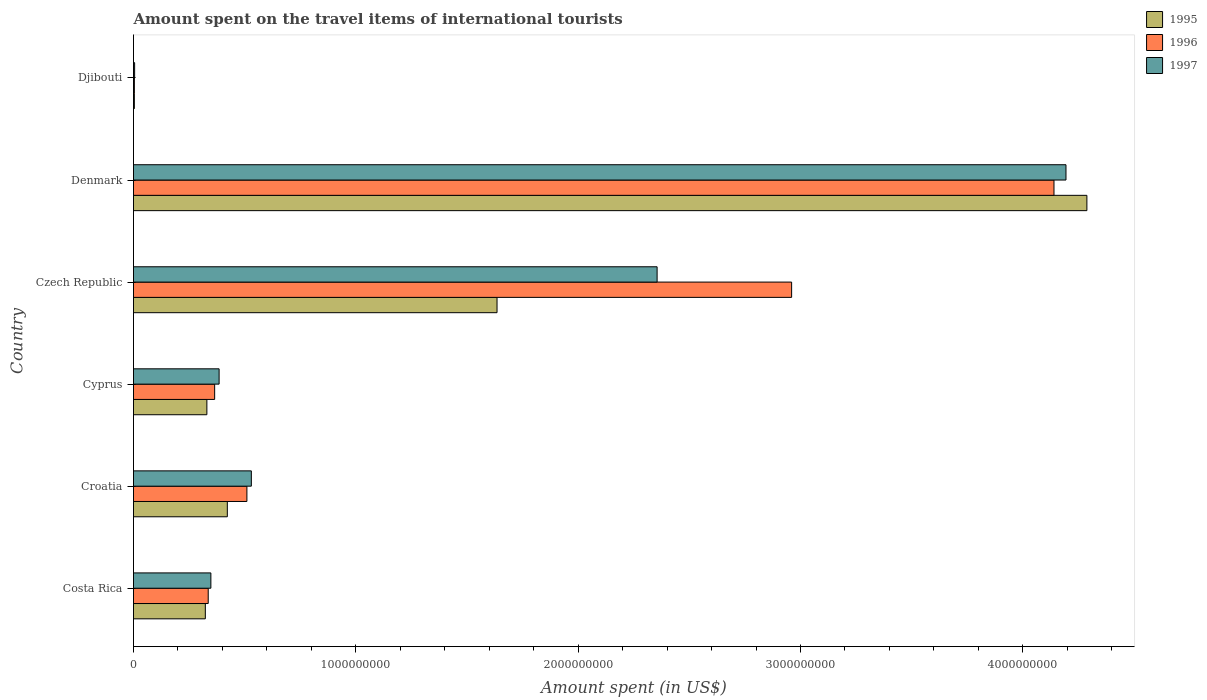How many groups of bars are there?
Your answer should be very brief. 6. How many bars are there on the 5th tick from the top?
Your answer should be very brief. 3. What is the label of the 4th group of bars from the top?
Your response must be concise. Cyprus. In how many cases, is the number of bars for a given country not equal to the number of legend labels?
Give a very brief answer. 0. What is the amount spent on the travel items of international tourists in 1995 in Djibouti?
Offer a terse response. 3.80e+06. Across all countries, what is the maximum amount spent on the travel items of international tourists in 1995?
Offer a terse response. 4.29e+09. Across all countries, what is the minimum amount spent on the travel items of international tourists in 1995?
Offer a terse response. 3.80e+06. In which country was the amount spent on the travel items of international tourists in 1995 maximum?
Provide a short and direct response. Denmark. In which country was the amount spent on the travel items of international tourists in 1996 minimum?
Ensure brevity in your answer.  Djibouti. What is the total amount spent on the travel items of international tourists in 1996 in the graph?
Provide a succinct answer. 8.31e+09. What is the difference between the amount spent on the travel items of international tourists in 1996 in Costa Rica and that in Cyprus?
Ensure brevity in your answer.  -2.90e+07. What is the difference between the amount spent on the travel items of international tourists in 1995 in Croatia and the amount spent on the travel items of international tourists in 1996 in Czech Republic?
Give a very brief answer. -2.54e+09. What is the average amount spent on the travel items of international tourists in 1997 per country?
Ensure brevity in your answer.  1.30e+09. What is the difference between the amount spent on the travel items of international tourists in 1995 and amount spent on the travel items of international tourists in 1997 in Cyprus?
Give a very brief answer. -5.50e+07. In how many countries, is the amount spent on the travel items of international tourists in 1995 greater than 3400000000 US$?
Provide a short and direct response. 1. What is the ratio of the amount spent on the travel items of international tourists in 1997 in Croatia to that in Czech Republic?
Provide a succinct answer. 0.23. What is the difference between the highest and the second highest amount spent on the travel items of international tourists in 1996?
Your response must be concise. 1.18e+09. What is the difference between the highest and the lowest amount spent on the travel items of international tourists in 1996?
Give a very brief answer. 4.14e+09. In how many countries, is the amount spent on the travel items of international tourists in 1996 greater than the average amount spent on the travel items of international tourists in 1996 taken over all countries?
Provide a short and direct response. 2. Is the sum of the amount spent on the travel items of international tourists in 1997 in Croatia and Cyprus greater than the maximum amount spent on the travel items of international tourists in 1996 across all countries?
Your response must be concise. No. What does the 1st bar from the top in Djibouti represents?
Keep it short and to the point. 1997. What does the 2nd bar from the bottom in Denmark represents?
Ensure brevity in your answer.  1996. Is it the case that in every country, the sum of the amount spent on the travel items of international tourists in 1996 and amount spent on the travel items of international tourists in 1997 is greater than the amount spent on the travel items of international tourists in 1995?
Your answer should be very brief. Yes. What is the difference between two consecutive major ticks on the X-axis?
Ensure brevity in your answer.  1.00e+09. Does the graph contain any zero values?
Offer a terse response. No. Does the graph contain grids?
Offer a terse response. No. Where does the legend appear in the graph?
Your answer should be compact. Top right. How many legend labels are there?
Provide a short and direct response. 3. How are the legend labels stacked?
Make the answer very short. Vertical. What is the title of the graph?
Provide a succinct answer. Amount spent on the travel items of international tourists. What is the label or title of the X-axis?
Your response must be concise. Amount spent (in US$). What is the Amount spent (in US$) in 1995 in Costa Rica?
Offer a terse response. 3.23e+08. What is the Amount spent (in US$) of 1996 in Costa Rica?
Make the answer very short. 3.36e+08. What is the Amount spent (in US$) in 1997 in Costa Rica?
Your answer should be very brief. 3.48e+08. What is the Amount spent (in US$) in 1995 in Croatia?
Make the answer very short. 4.22e+08. What is the Amount spent (in US$) in 1996 in Croatia?
Offer a terse response. 5.10e+08. What is the Amount spent (in US$) of 1997 in Croatia?
Offer a very short reply. 5.30e+08. What is the Amount spent (in US$) in 1995 in Cyprus?
Offer a very short reply. 3.30e+08. What is the Amount spent (in US$) of 1996 in Cyprus?
Offer a very short reply. 3.65e+08. What is the Amount spent (in US$) of 1997 in Cyprus?
Your answer should be very brief. 3.85e+08. What is the Amount spent (in US$) in 1995 in Czech Republic?
Provide a succinct answer. 1.64e+09. What is the Amount spent (in US$) in 1996 in Czech Republic?
Give a very brief answer. 2.96e+09. What is the Amount spent (in US$) in 1997 in Czech Republic?
Provide a short and direct response. 2.36e+09. What is the Amount spent (in US$) in 1995 in Denmark?
Your answer should be compact. 4.29e+09. What is the Amount spent (in US$) of 1996 in Denmark?
Offer a terse response. 4.14e+09. What is the Amount spent (in US$) of 1997 in Denmark?
Provide a succinct answer. 4.19e+09. What is the Amount spent (in US$) in 1995 in Djibouti?
Provide a succinct answer. 3.80e+06. What is the Amount spent (in US$) of 1996 in Djibouti?
Provide a short and direct response. 3.90e+06. Across all countries, what is the maximum Amount spent (in US$) in 1995?
Offer a very short reply. 4.29e+09. Across all countries, what is the maximum Amount spent (in US$) of 1996?
Your response must be concise. 4.14e+09. Across all countries, what is the maximum Amount spent (in US$) in 1997?
Your answer should be compact. 4.19e+09. Across all countries, what is the minimum Amount spent (in US$) in 1995?
Provide a succinct answer. 3.80e+06. Across all countries, what is the minimum Amount spent (in US$) of 1996?
Offer a very short reply. 3.90e+06. Across all countries, what is the minimum Amount spent (in US$) of 1997?
Make the answer very short. 5.00e+06. What is the total Amount spent (in US$) of 1995 in the graph?
Offer a very short reply. 7.00e+09. What is the total Amount spent (in US$) in 1996 in the graph?
Provide a short and direct response. 8.31e+09. What is the total Amount spent (in US$) in 1997 in the graph?
Provide a short and direct response. 7.82e+09. What is the difference between the Amount spent (in US$) of 1995 in Costa Rica and that in Croatia?
Give a very brief answer. -9.90e+07. What is the difference between the Amount spent (in US$) of 1996 in Costa Rica and that in Croatia?
Ensure brevity in your answer.  -1.74e+08. What is the difference between the Amount spent (in US$) of 1997 in Costa Rica and that in Croatia?
Provide a short and direct response. -1.82e+08. What is the difference between the Amount spent (in US$) of 1995 in Costa Rica and that in Cyprus?
Your answer should be very brief. -7.00e+06. What is the difference between the Amount spent (in US$) in 1996 in Costa Rica and that in Cyprus?
Your answer should be compact. -2.90e+07. What is the difference between the Amount spent (in US$) in 1997 in Costa Rica and that in Cyprus?
Keep it short and to the point. -3.70e+07. What is the difference between the Amount spent (in US$) in 1995 in Costa Rica and that in Czech Republic?
Provide a succinct answer. -1.31e+09. What is the difference between the Amount spent (in US$) in 1996 in Costa Rica and that in Czech Republic?
Provide a succinct answer. -2.62e+09. What is the difference between the Amount spent (in US$) in 1997 in Costa Rica and that in Czech Republic?
Your response must be concise. -2.01e+09. What is the difference between the Amount spent (in US$) in 1995 in Costa Rica and that in Denmark?
Give a very brief answer. -3.96e+09. What is the difference between the Amount spent (in US$) in 1996 in Costa Rica and that in Denmark?
Ensure brevity in your answer.  -3.80e+09. What is the difference between the Amount spent (in US$) in 1997 in Costa Rica and that in Denmark?
Your response must be concise. -3.85e+09. What is the difference between the Amount spent (in US$) in 1995 in Costa Rica and that in Djibouti?
Keep it short and to the point. 3.19e+08. What is the difference between the Amount spent (in US$) of 1996 in Costa Rica and that in Djibouti?
Provide a short and direct response. 3.32e+08. What is the difference between the Amount spent (in US$) of 1997 in Costa Rica and that in Djibouti?
Make the answer very short. 3.43e+08. What is the difference between the Amount spent (in US$) in 1995 in Croatia and that in Cyprus?
Make the answer very short. 9.20e+07. What is the difference between the Amount spent (in US$) in 1996 in Croatia and that in Cyprus?
Your answer should be compact. 1.45e+08. What is the difference between the Amount spent (in US$) in 1997 in Croatia and that in Cyprus?
Make the answer very short. 1.45e+08. What is the difference between the Amount spent (in US$) in 1995 in Croatia and that in Czech Republic?
Give a very brief answer. -1.21e+09. What is the difference between the Amount spent (in US$) in 1996 in Croatia and that in Czech Republic?
Ensure brevity in your answer.  -2.45e+09. What is the difference between the Amount spent (in US$) of 1997 in Croatia and that in Czech Republic?
Your answer should be compact. -1.82e+09. What is the difference between the Amount spent (in US$) in 1995 in Croatia and that in Denmark?
Provide a succinct answer. -3.87e+09. What is the difference between the Amount spent (in US$) of 1996 in Croatia and that in Denmark?
Offer a terse response. -3.63e+09. What is the difference between the Amount spent (in US$) of 1997 in Croatia and that in Denmark?
Offer a terse response. -3.66e+09. What is the difference between the Amount spent (in US$) in 1995 in Croatia and that in Djibouti?
Keep it short and to the point. 4.18e+08. What is the difference between the Amount spent (in US$) in 1996 in Croatia and that in Djibouti?
Your answer should be very brief. 5.06e+08. What is the difference between the Amount spent (in US$) in 1997 in Croatia and that in Djibouti?
Keep it short and to the point. 5.25e+08. What is the difference between the Amount spent (in US$) in 1995 in Cyprus and that in Czech Republic?
Your answer should be compact. -1.30e+09. What is the difference between the Amount spent (in US$) of 1996 in Cyprus and that in Czech Republic?
Offer a terse response. -2.60e+09. What is the difference between the Amount spent (in US$) of 1997 in Cyprus and that in Czech Republic?
Your answer should be very brief. -1.97e+09. What is the difference between the Amount spent (in US$) of 1995 in Cyprus and that in Denmark?
Offer a very short reply. -3.96e+09. What is the difference between the Amount spent (in US$) in 1996 in Cyprus and that in Denmark?
Provide a succinct answer. -3.78e+09. What is the difference between the Amount spent (in US$) of 1997 in Cyprus and that in Denmark?
Make the answer very short. -3.81e+09. What is the difference between the Amount spent (in US$) of 1995 in Cyprus and that in Djibouti?
Your answer should be compact. 3.26e+08. What is the difference between the Amount spent (in US$) of 1996 in Cyprus and that in Djibouti?
Ensure brevity in your answer.  3.61e+08. What is the difference between the Amount spent (in US$) in 1997 in Cyprus and that in Djibouti?
Your response must be concise. 3.80e+08. What is the difference between the Amount spent (in US$) of 1995 in Czech Republic and that in Denmark?
Ensure brevity in your answer.  -2.65e+09. What is the difference between the Amount spent (in US$) in 1996 in Czech Republic and that in Denmark?
Offer a terse response. -1.18e+09. What is the difference between the Amount spent (in US$) of 1997 in Czech Republic and that in Denmark?
Offer a very short reply. -1.84e+09. What is the difference between the Amount spent (in US$) in 1995 in Czech Republic and that in Djibouti?
Offer a terse response. 1.63e+09. What is the difference between the Amount spent (in US$) of 1996 in Czech Republic and that in Djibouti?
Provide a short and direct response. 2.96e+09. What is the difference between the Amount spent (in US$) in 1997 in Czech Republic and that in Djibouti?
Your response must be concise. 2.35e+09. What is the difference between the Amount spent (in US$) of 1995 in Denmark and that in Djibouti?
Your answer should be compact. 4.28e+09. What is the difference between the Amount spent (in US$) of 1996 in Denmark and that in Djibouti?
Give a very brief answer. 4.14e+09. What is the difference between the Amount spent (in US$) of 1997 in Denmark and that in Djibouti?
Keep it short and to the point. 4.19e+09. What is the difference between the Amount spent (in US$) in 1995 in Costa Rica and the Amount spent (in US$) in 1996 in Croatia?
Provide a short and direct response. -1.87e+08. What is the difference between the Amount spent (in US$) of 1995 in Costa Rica and the Amount spent (in US$) of 1997 in Croatia?
Make the answer very short. -2.07e+08. What is the difference between the Amount spent (in US$) of 1996 in Costa Rica and the Amount spent (in US$) of 1997 in Croatia?
Ensure brevity in your answer.  -1.94e+08. What is the difference between the Amount spent (in US$) of 1995 in Costa Rica and the Amount spent (in US$) of 1996 in Cyprus?
Your answer should be very brief. -4.20e+07. What is the difference between the Amount spent (in US$) of 1995 in Costa Rica and the Amount spent (in US$) of 1997 in Cyprus?
Provide a short and direct response. -6.20e+07. What is the difference between the Amount spent (in US$) in 1996 in Costa Rica and the Amount spent (in US$) in 1997 in Cyprus?
Your answer should be compact. -4.90e+07. What is the difference between the Amount spent (in US$) in 1995 in Costa Rica and the Amount spent (in US$) in 1996 in Czech Republic?
Your answer should be compact. -2.64e+09. What is the difference between the Amount spent (in US$) of 1995 in Costa Rica and the Amount spent (in US$) of 1997 in Czech Republic?
Give a very brief answer. -2.03e+09. What is the difference between the Amount spent (in US$) of 1996 in Costa Rica and the Amount spent (in US$) of 1997 in Czech Republic?
Your answer should be compact. -2.02e+09. What is the difference between the Amount spent (in US$) in 1995 in Costa Rica and the Amount spent (in US$) in 1996 in Denmark?
Your response must be concise. -3.82e+09. What is the difference between the Amount spent (in US$) in 1995 in Costa Rica and the Amount spent (in US$) in 1997 in Denmark?
Your response must be concise. -3.87e+09. What is the difference between the Amount spent (in US$) of 1996 in Costa Rica and the Amount spent (in US$) of 1997 in Denmark?
Your answer should be compact. -3.86e+09. What is the difference between the Amount spent (in US$) of 1995 in Costa Rica and the Amount spent (in US$) of 1996 in Djibouti?
Ensure brevity in your answer.  3.19e+08. What is the difference between the Amount spent (in US$) of 1995 in Costa Rica and the Amount spent (in US$) of 1997 in Djibouti?
Ensure brevity in your answer.  3.18e+08. What is the difference between the Amount spent (in US$) in 1996 in Costa Rica and the Amount spent (in US$) in 1997 in Djibouti?
Keep it short and to the point. 3.31e+08. What is the difference between the Amount spent (in US$) of 1995 in Croatia and the Amount spent (in US$) of 1996 in Cyprus?
Provide a succinct answer. 5.70e+07. What is the difference between the Amount spent (in US$) in 1995 in Croatia and the Amount spent (in US$) in 1997 in Cyprus?
Provide a short and direct response. 3.70e+07. What is the difference between the Amount spent (in US$) in 1996 in Croatia and the Amount spent (in US$) in 1997 in Cyprus?
Provide a succinct answer. 1.25e+08. What is the difference between the Amount spent (in US$) of 1995 in Croatia and the Amount spent (in US$) of 1996 in Czech Republic?
Provide a succinct answer. -2.54e+09. What is the difference between the Amount spent (in US$) in 1995 in Croatia and the Amount spent (in US$) in 1997 in Czech Republic?
Provide a succinct answer. -1.93e+09. What is the difference between the Amount spent (in US$) in 1996 in Croatia and the Amount spent (in US$) in 1997 in Czech Republic?
Give a very brief answer. -1.84e+09. What is the difference between the Amount spent (in US$) in 1995 in Croatia and the Amount spent (in US$) in 1996 in Denmark?
Provide a succinct answer. -3.72e+09. What is the difference between the Amount spent (in US$) in 1995 in Croatia and the Amount spent (in US$) in 1997 in Denmark?
Make the answer very short. -3.77e+09. What is the difference between the Amount spent (in US$) of 1996 in Croatia and the Amount spent (in US$) of 1997 in Denmark?
Keep it short and to the point. -3.68e+09. What is the difference between the Amount spent (in US$) in 1995 in Croatia and the Amount spent (in US$) in 1996 in Djibouti?
Your answer should be compact. 4.18e+08. What is the difference between the Amount spent (in US$) of 1995 in Croatia and the Amount spent (in US$) of 1997 in Djibouti?
Keep it short and to the point. 4.17e+08. What is the difference between the Amount spent (in US$) of 1996 in Croatia and the Amount spent (in US$) of 1997 in Djibouti?
Keep it short and to the point. 5.05e+08. What is the difference between the Amount spent (in US$) in 1995 in Cyprus and the Amount spent (in US$) in 1996 in Czech Republic?
Keep it short and to the point. -2.63e+09. What is the difference between the Amount spent (in US$) in 1995 in Cyprus and the Amount spent (in US$) in 1997 in Czech Republic?
Your answer should be compact. -2.02e+09. What is the difference between the Amount spent (in US$) of 1996 in Cyprus and the Amount spent (in US$) of 1997 in Czech Republic?
Offer a very short reply. -1.99e+09. What is the difference between the Amount spent (in US$) in 1995 in Cyprus and the Amount spent (in US$) in 1996 in Denmark?
Ensure brevity in your answer.  -3.81e+09. What is the difference between the Amount spent (in US$) in 1995 in Cyprus and the Amount spent (in US$) in 1997 in Denmark?
Provide a short and direct response. -3.86e+09. What is the difference between the Amount spent (in US$) in 1996 in Cyprus and the Amount spent (in US$) in 1997 in Denmark?
Your answer should be compact. -3.83e+09. What is the difference between the Amount spent (in US$) of 1995 in Cyprus and the Amount spent (in US$) of 1996 in Djibouti?
Provide a short and direct response. 3.26e+08. What is the difference between the Amount spent (in US$) in 1995 in Cyprus and the Amount spent (in US$) in 1997 in Djibouti?
Provide a short and direct response. 3.25e+08. What is the difference between the Amount spent (in US$) in 1996 in Cyprus and the Amount spent (in US$) in 1997 in Djibouti?
Your answer should be very brief. 3.60e+08. What is the difference between the Amount spent (in US$) in 1995 in Czech Republic and the Amount spent (in US$) in 1996 in Denmark?
Make the answer very short. -2.50e+09. What is the difference between the Amount spent (in US$) of 1995 in Czech Republic and the Amount spent (in US$) of 1997 in Denmark?
Offer a very short reply. -2.56e+09. What is the difference between the Amount spent (in US$) of 1996 in Czech Republic and the Amount spent (in US$) of 1997 in Denmark?
Offer a very short reply. -1.23e+09. What is the difference between the Amount spent (in US$) in 1995 in Czech Republic and the Amount spent (in US$) in 1996 in Djibouti?
Give a very brief answer. 1.63e+09. What is the difference between the Amount spent (in US$) of 1995 in Czech Republic and the Amount spent (in US$) of 1997 in Djibouti?
Your response must be concise. 1.63e+09. What is the difference between the Amount spent (in US$) in 1996 in Czech Republic and the Amount spent (in US$) in 1997 in Djibouti?
Offer a very short reply. 2.96e+09. What is the difference between the Amount spent (in US$) of 1995 in Denmark and the Amount spent (in US$) of 1996 in Djibouti?
Make the answer very short. 4.28e+09. What is the difference between the Amount spent (in US$) in 1995 in Denmark and the Amount spent (in US$) in 1997 in Djibouti?
Offer a terse response. 4.28e+09. What is the difference between the Amount spent (in US$) of 1996 in Denmark and the Amount spent (in US$) of 1997 in Djibouti?
Your answer should be very brief. 4.14e+09. What is the average Amount spent (in US$) in 1995 per country?
Provide a succinct answer. 1.17e+09. What is the average Amount spent (in US$) of 1996 per country?
Your answer should be compact. 1.39e+09. What is the average Amount spent (in US$) of 1997 per country?
Offer a very short reply. 1.30e+09. What is the difference between the Amount spent (in US$) of 1995 and Amount spent (in US$) of 1996 in Costa Rica?
Offer a terse response. -1.30e+07. What is the difference between the Amount spent (in US$) of 1995 and Amount spent (in US$) of 1997 in Costa Rica?
Provide a short and direct response. -2.50e+07. What is the difference between the Amount spent (in US$) in 1996 and Amount spent (in US$) in 1997 in Costa Rica?
Keep it short and to the point. -1.20e+07. What is the difference between the Amount spent (in US$) in 1995 and Amount spent (in US$) in 1996 in Croatia?
Provide a short and direct response. -8.80e+07. What is the difference between the Amount spent (in US$) of 1995 and Amount spent (in US$) of 1997 in Croatia?
Provide a short and direct response. -1.08e+08. What is the difference between the Amount spent (in US$) of 1996 and Amount spent (in US$) of 1997 in Croatia?
Ensure brevity in your answer.  -2.00e+07. What is the difference between the Amount spent (in US$) of 1995 and Amount spent (in US$) of 1996 in Cyprus?
Keep it short and to the point. -3.50e+07. What is the difference between the Amount spent (in US$) of 1995 and Amount spent (in US$) of 1997 in Cyprus?
Offer a terse response. -5.50e+07. What is the difference between the Amount spent (in US$) of 1996 and Amount spent (in US$) of 1997 in Cyprus?
Offer a very short reply. -2.00e+07. What is the difference between the Amount spent (in US$) in 1995 and Amount spent (in US$) in 1996 in Czech Republic?
Your answer should be very brief. -1.32e+09. What is the difference between the Amount spent (in US$) of 1995 and Amount spent (in US$) of 1997 in Czech Republic?
Make the answer very short. -7.20e+08. What is the difference between the Amount spent (in US$) of 1996 and Amount spent (in US$) of 1997 in Czech Republic?
Offer a terse response. 6.05e+08. What is the difference between the Amount spent (in US$) in 1995 and Amount spent (in US$) in 1996 in Denmark?
Offer a very short reply. 1.48e+08. What is the difference between the Amount spent (in US$) in 1995 and Amount spent (in US$) in 1997 in Denmark?
Your response must be concise. 9.40e+07. What is the difference between the Amount spent (in US$) of 1996 and Amount spent (in US$) of 1997 in Denmark?
Provide a succinct answer. -5.40e+07. What is the difference between the Amount spent (in US$) of 1995 and Amount spent (in US$) of 1996 in Djibouti?
Make the answer very short. -1.00e+05. What is the difference between the Amount spent (in US$) in 1995 and Amount spent (in US$) in 1997 in Djibouti?
Your answer should be compact. -1.20e+06. What is the difference between the Amount spent (in US$) of 1996 and Amount spent (in US$) of 1997 in Djibouti?
Your response must be concise. -1.10e+06. What is the ratio of the Amount spent (in US$) of 1995 in Costa Rica to that in Croatia?
Your response must be concise. 0.77. What is the ratio of the Amount spent (in US$) in 1996 in Costa Rica to that in Croatia?
Ensure brevity in your answer.  0.66. What is the ratio of the Amount spent (in US$) of 1997 in Costa Rica to that in Croatia?
Provide a short and direct response. 0.66. What is the ratio of the Amount spent (in US$) of 1995 in Costa Rica to that in Cyprus?
Give a very brief answer. 0.98. What is the ratio of the Amount spent (in US$) in 1996 in Costa Rica to that in Cyprus?
Your response must be concise. 0.92. What is the ratio of the Amount spent (in US$) in 1997 in Costa Rica to that in Cyprus?
Offer a very short reply. 0.9. What is the ratio of the Amount spent (in US$) in 1995 in Costa Rica to that in Czech Republic?
Ensure brevity in your answer.  0.2. What is the ratio of the Amount spent (in US$) in 1996 in Costa Rica to that in Czech Republic?
Your answer should be very brief. 0.11. What is the ratio of the Amount spent (in US$) of 1997 in Costa Rica to that in Czech Republic?
Make the answer very short. 0.15. What is the ratio of the Amount spent (in US$) of 1995 in Costa Rica to that in Denmark?
Keep it short and to the point. 0.08. What is the ratio of the Amount spent (in US$) of 1996 in Costa Rica to that in Denmark?
Keep it short and to the point. 0.08. What is the ratio of the Amount spent (in US$) in 1997 in Costa Rica to that in Denmark?
Ensure brevity in your answer.  0.08. What is the ratio of the Amount spent (in US$) of 1995 in Costa Rica to that in Djibouti?
Your response must be concise. 85. What is the ratio of the Amount spent (in US$) in 1996 in Costa Rica to that in Djibouti?
Offer a terse response. 86.15. What is the ratio of the Amount spent (in US$) of 1997 in Costa Rica to that in Djibouti?
Give a very brief answer. 69.6. What is the ratio of the Amount spent (in US$) of 1995 in Croatia to that in Cyprus?
Your answer should be very brief. 1.28. What is the ratio of the Amount spent (in US$) of 1996 in Croatia to that in Cyprus?
Make the answer very short. 1.4. What is the ratio of the Amount spent (in US$) of 1997 in Croatia to that in Cyprus?
Give a very brief answer. 1.38. What is the ratio of the Amount spent (in US$) in 1995 in Croatia to that in Czech Republic?
Your answer should be compact. 0.26. What is the ratio of the Amount spent (in US$) in 1996 in Croatia to that in Czech Republic?
Provide a short and direct response. 0.17. What is the ratio of the Amount spent (in US$) of 1997 in Croatia to that in Czech Republic?
Ensure brevity in your answer.  0.23. What is the ratio of the Amount spent (in US$) of 1995 in Croatia to that in Denmark?
Give a very brief answer. 0.1. What is the ratio of the Amount spent (in US$) of 1996 in Croatia to that in Denmark?
Provide a short and direct response. 0.12. What is the ratio of the Amount spent (in US$) in 1997 in Croatia to that in Denmark?
Offer a terse response. 0.13. What is the ratio of the Amount spent (in US$) of 1995 in Croatia to that in Djibouti?
Give a very brief answer. 111.05. What is the ratio of the Amount spent (in US$) of 1996 in Croatia to that in Djibouti?
Offer a very short reply. 130.77. What is the ratio of the Amount spent (in US$) of 1997 in Croatia to that in Djibouti?
Provide a short and direct response. 106. What is the ratio of the Amount spent (in US$) in 1995 in Cyprus to that in Czech Republic?
Keep it short and to the point. 0.2. What is the ratio of the Amount spent (in US$) in 1996 in Cyprus to that in Czech Republic?
Offer a very short reply. 0.12. What is the ratio of the Amount spent (in US$) of 1997 in Cyprus to that in Czech Republic?
Provide a succinct answer. 0.16. What is the ratio of the Amount spent (in US$) of 1995 in Cyprus to that in Denmark?
Ensure brevity in your answer.  0.08. What is the ratio of the Amount spent (in US$) in 1996 in Cyprus to that in Denmark?
Give a very brief answer. 0.09. What is the ratio of the Amount spent (in US$) of 1997 in Cyprus to that in Denmark?
Provide a succinct answer. 0.09. What is the ratio of the Amount spent (in US$) of 1995 in Cyprus to that in Djibouti?
Offer a terse response. 86.84. What is the ratio of the Amount spent (in US$) of 1996 in Cyprus to that in Djibouti?
Offer a terse response. 93.59. What is the ratio of the Amount spent (in US$) of 1997 in Cyprus to that in Djibouti?
Keep it short and to the point. 77. What is the ratio of the Amount spent (in US$) of 1995 in Czech Republic to that in Denmark?
Your answer should be compact. 0.38. What is the ratio of the Amount spent (in US$) in 1996 in Czech Republic to that in Denmark?
Keep it short and to the point. 0.71. What is the ratio of the Amount spent (in US$) in 1997 in Czech Republic to that in Denmark?
Offer a very short reply. 0.56. What is the ratio of the Amount spent (in US$) of 1995 in Czech Republic to that in Djibouti?
Offer a very short reply. 430.26. What is the ratio of the Amount spent (in US$) in 1996 in Czech Republic to that in Djibouti?
Your response must be concise. 758.97. What is the ratio of the Amount spent (in US$) in 1997 in Czech Republic to that in Djibouti?
Offer a very short reply. 471. What is the ratio of the Amount spent (in US$) of 1995 in Denmark to that in Djibouti?
Your answer should be compact. 1128.42. What is the ratio of the Amount spent (in US$) in 1996 in Denmark to that in Djibouti?
Provide a succinct answer. 1061.54. What is the ratio of the Amount spent (in US$) in 1997 in Denmark to that in Djibouti?
Make the answer very short. 838.8. What is the difference between the highest and the second highest Amount spent (in US$) in 1995?
Make the answer very short. 2.65e+09. What is the difference between the highest and the second highest Amount spent (in US$) in 1996?
Your answer should be very brief. 1.18e+09. What is the difference between the highest and the second highest Amount spent (in US$) of 1997?
Make the answer very short. 1.84e+09. What is the difference between the highest and the lowest Amount spent (in US$) of 1995?
Offer a terse response. 4.28e+09. What is the difference between the highest and the lowest Amount spent (in US$) of 1996?
Offer a very short reply. 4.14e+09. What is the difference between the highest and the lowest Amount spent (in US$) of 1997?
Provide a short and direct response. 4.19e+09. 